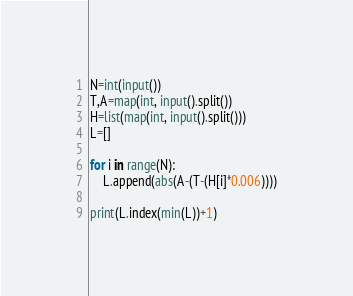<code> <loc_0><loc_0><loc_500><loc_500><_Python_>N=int(input())
T,A=map(int, input().split())
H=list(map(int, input().split()))
L=[]

for i in range(N):
    L.append(abs(A-(T-(H[i]*0.006))))
    
print(L.index(min(L))+1)</code> 